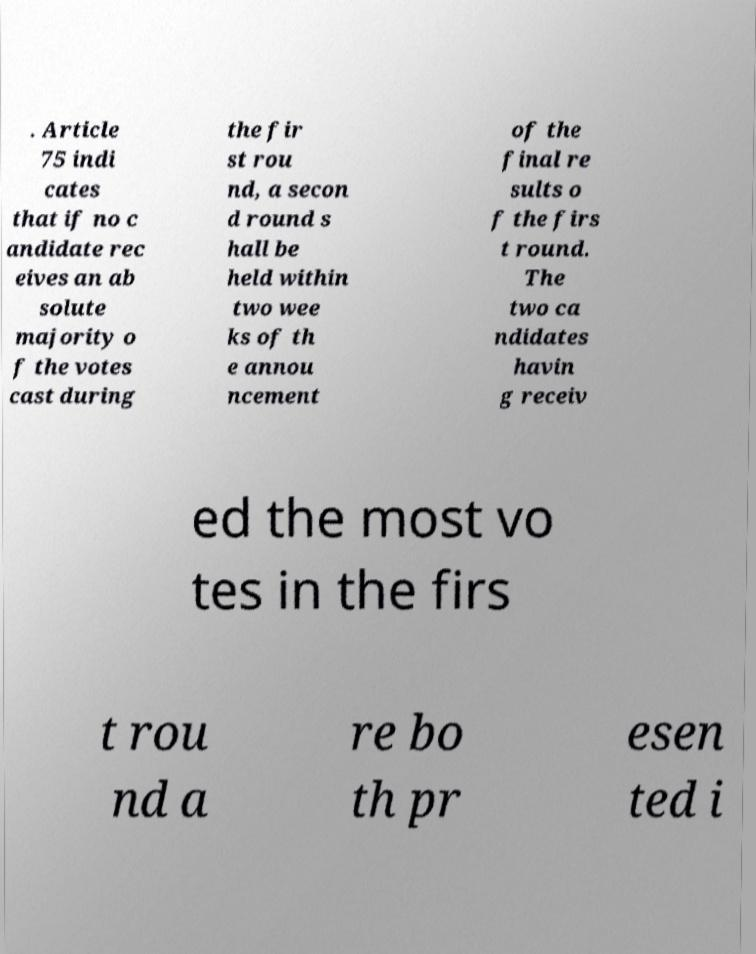There's text embedded in this image that I need extracted. Can you transcribe it verbatim? . Article 75 indi cates that if no c andidate rec eives an ab solute majority o f the votes cast during the fir st rou nd, a secon d round s hall be held within two wee ks of th e annou ncement of the final re sults o f the firs t round. The two ca ndidates havin g receiv ed the most vo tes in the firs t rou nd a re bo th pr esen ted i 